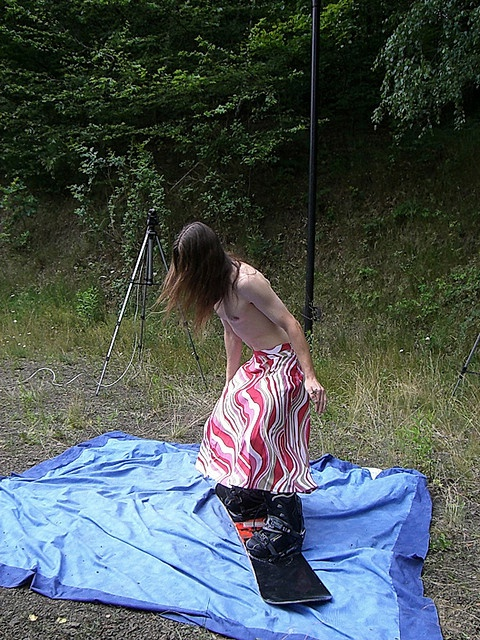Describe the objects in this image and their specific colors. I can see people in black, gray, lavender, and darkgray tones and snowboard in black, navy, gray, and darkgray tones in this image. 